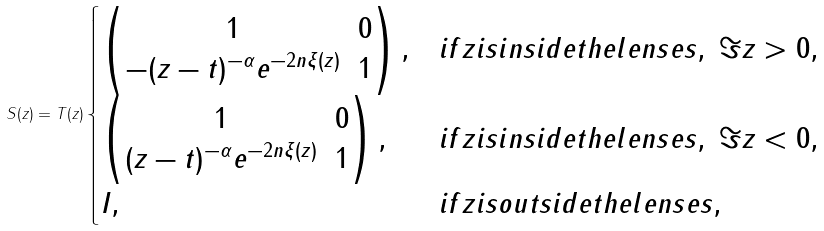<formula> <loc_0><loc_0><loc_500><loc_500>S ( z ) = T ( z ) \begin{cases} \begin{pmatrix} 1 & 0 \\ - ( z - t ) ^ { - \alpha } e ^ { - 2 n \xi ( z ) } & 1 \end{pmatrix} , & i f z i s i n s i d e t h e l e n s e s , \ \Im z > 0 , \\ \begin{pmatrix} 1 & 0 \\ ( z - t ) ^ { - \alpha } e ^ { - 2 n \xi ( z ) } & 1 \end{pmatrix} , & i f z i s i n s i d e t h e l e n s e s , \ \Im z < 0 , \\ I , & i f z i s o u t s i d e t h e l e n s e s , \\ \end{cases}</formula> 